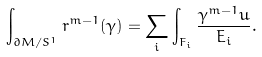Convert formula to latex. <formula><loc_0><loc_0><loc_500><loc_500>\int _ { \partial M / S ^ { 1 } } r ^ { m - 1 } ( \gamma ) = \sum _ { i } \int _ { F _ { i } } \frac { \gamma ^ { m - 1 } u } { E _ { i } } .</formula> 